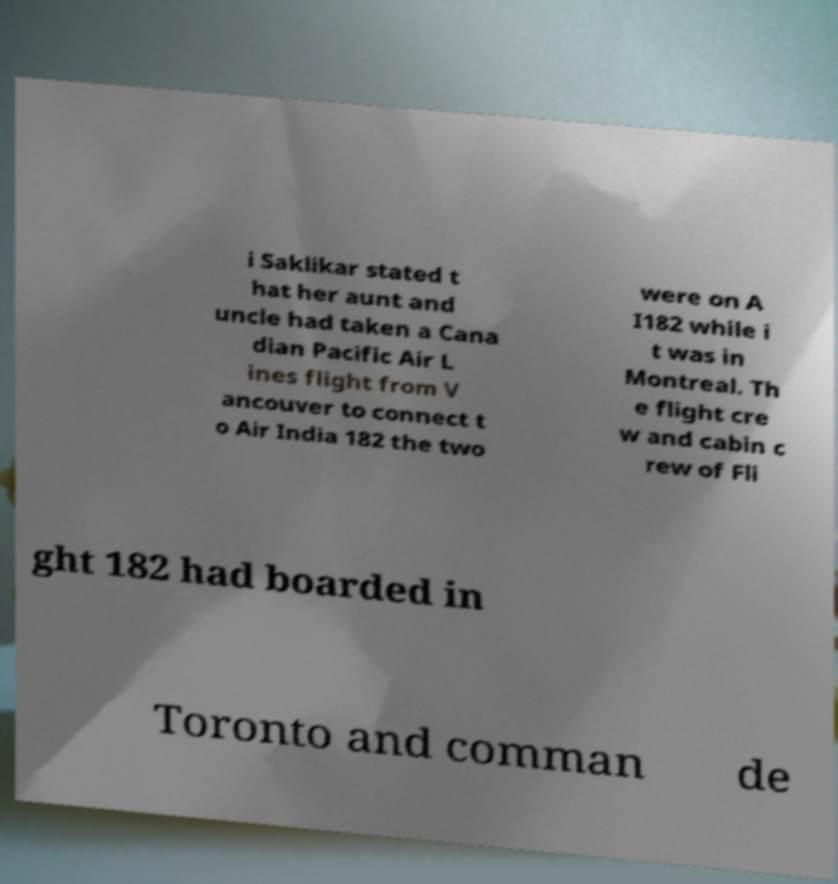Could you assist in decoding the text presented in this image and type it out clearly? i Saklikar stated t hat her aunt and uncle had taken a Cana dian Pacific Air L ines flight from V ancouver to connect t o Air India 182 the two were on A I182 while i t was in Montreal. Th e flight cre w and cabin c rew of Fli ght 182 had boarded in Toronto and comman de 